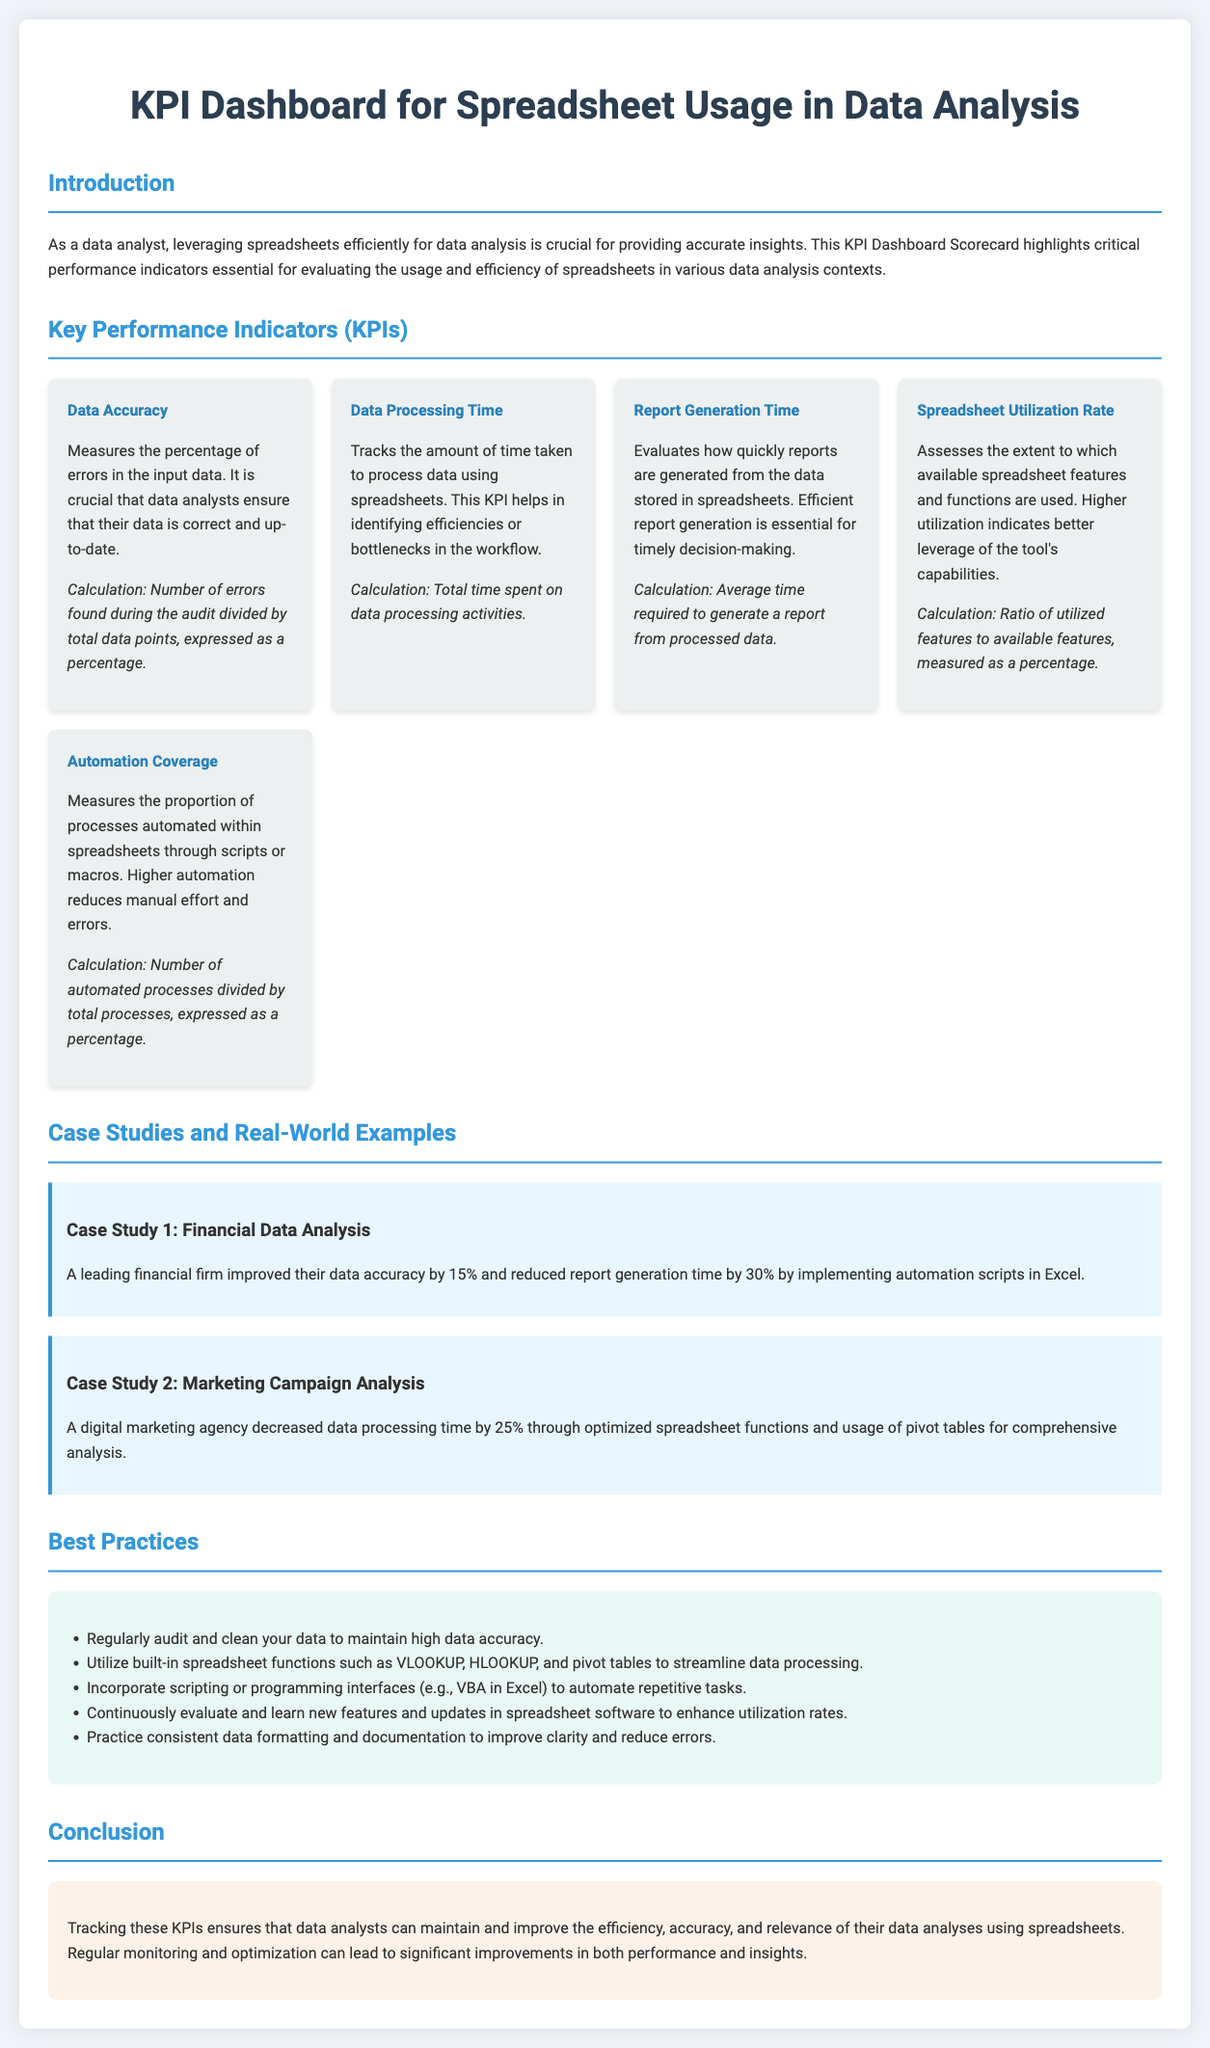What is the title of the document? The title of the document is prominently displayed at the top.
Answer: KPI Dashboard for Spreadsheet Usage in Data Analysis What is the KPI for measuring data accuracy? The section describes the KPI specifically related to data accuracy.
Answer: Data Accuracy What percentage increase in data accuracy did the financial firm achieve? This information is detailed in the case study about the financial firm.
Answer: 15% What is the main purpose of tracking these KPIs? The conclusion summarizes the goal of monitoring KPIs in the context of data analysis.
Answer: Improve efficiency, accuracy, and relevance How is automation coverage calculated? The document outlines the calculation method for automation coverage under the KPIs section.
Answer: Number of automated processes divided by total processes, expressed as a percentage Which spreadsheet function is recommended for streamlining data processing? The best practices section provides specific functions that help in data processing tasks.
Answer: VLOOKUP What is the average time required to generate a report called? This is defined within the KPI description regarding report generation.
Answer: Report Generation Time Which case study showcases a reduction in report generation time? The document features case studies detailing performance improvements through automation.
Answer: Case Study 1: Financial Data Analysis What color is the conclusion background? The conclusion section has a specific background color mentioned in the document styling.
Answer: #fdf2e9 